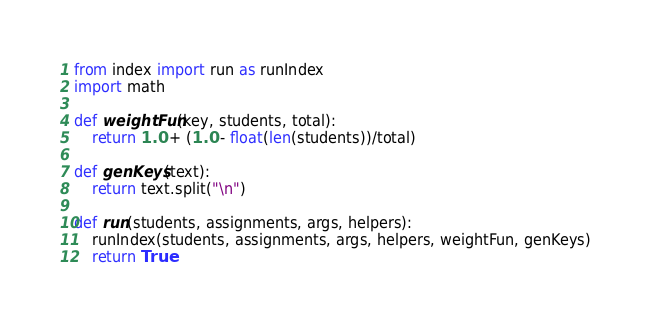<code> <loc_0><loc_0><loc_500><loc_500><_Python_>from index import run as runIndex
import math

def weightFun(key, students, total):
	return 1.0 + (1.0 - float(len(students))/total)

def genKeys(text):
	return text.split("\n")

def run(students, assignments, args, helpers):
	runIndex(students, assignments, args, helpers, weightFun, genKeys)
	return True
</code> 